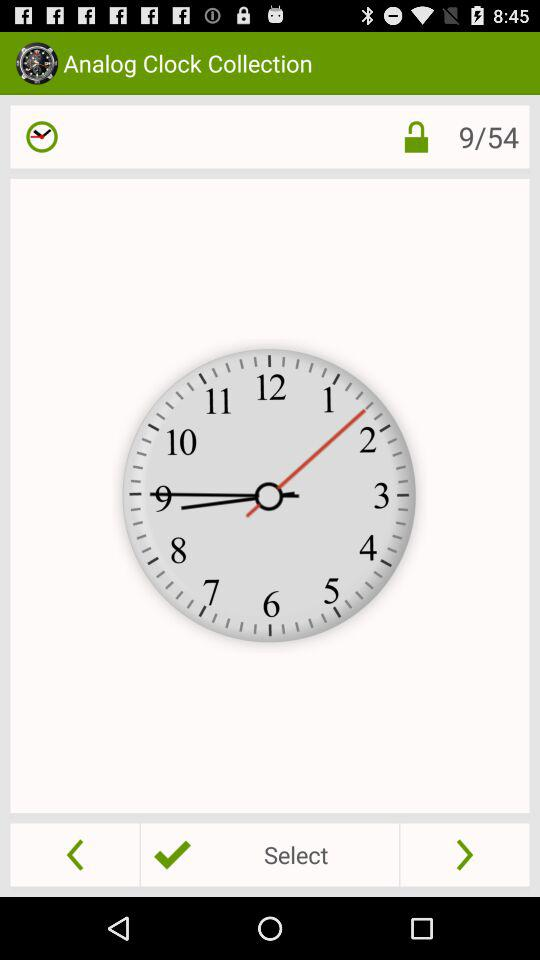Which image number am I on? You are on image number 9. 